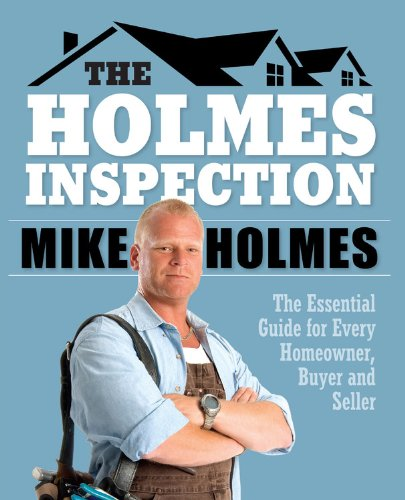Is this book related to Business & Money? Yes, the book is related to Business & Money as it provides practical advice and financial considerations for home transactions and maintenance. 